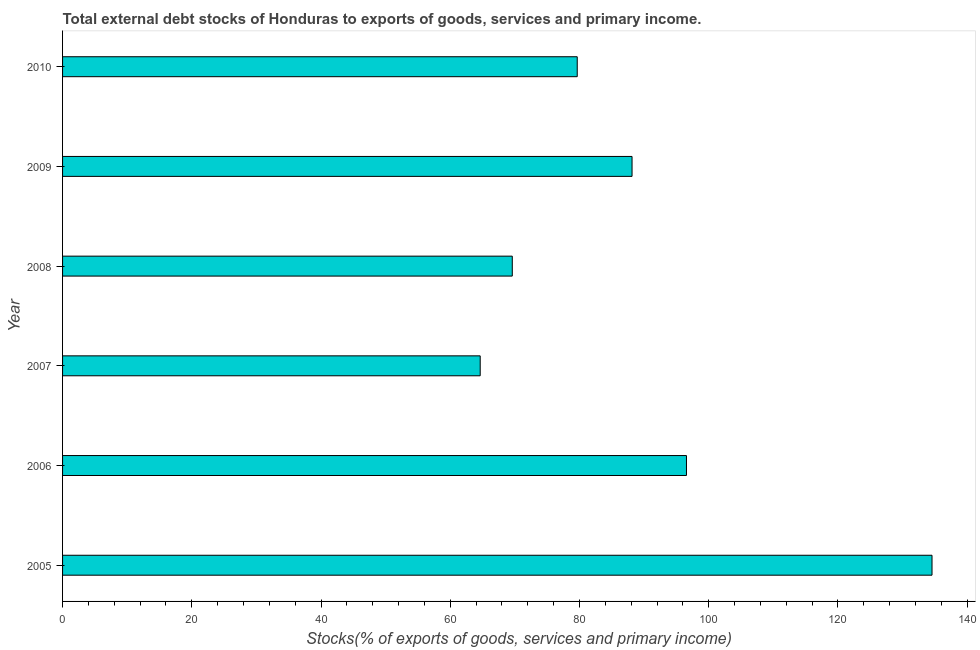What is the title of the graph?
Provide a succinct answer. Total external debt stocks of Honduras to exports of goods, services and primary income. What is the label or title of the X-axis?
Provide a succinct answer. Stocks(% of exports of goods, services and primary income). What is the label or title of the Y-axis?
Offer a very short reply. Year. What is the external debt stocks in 2005?
Give a very brief answer. 134.55. Across all years, what is the maximum external debt stocks?
Ensure brevity in your answer.  134.55. Across all years, what is the minimum external debt stocks?
Provide a short and direct response. 64.63. In which year was the external debt stocks maximum?
Your response must be concise. 2005. In which year was the external debt stocks minimum?
Your response must be concise. 2007. What is the sum of the external debt stocks?
Your response must be concise. 533.11. What is the difference between the external debt stocks in 2005 and 2007?
Your answer should be very brief. 69.92. What is the average external debt stocks per year?
Provide a succinct answer. 88.85. What is the median external debt stocks?
Your answer should be very brief. 83.89. In how many years, is the external debt stocks greater than 76 %?
Give a very brief answer. 4. What is the ratio of the external debt stocks in 2005 to that in 2009?
Provide a succinct answer. 1.53. What is the difference between the highest and the second highest external debt stocks?
Make the answer very short. 38. What is the difference between the highest and the lowest external debt stocks?
Your response must be concise. 69.92. How many bars are there?
Ensure brevity in your answer.  6. What is the difference between two consecutive major ticks on the X-axis?
Your response must be concise. 20. What is the Stocks(% of exports of goods, services and primary income) in 2005?
Keep it short and to the point. 134.55. What is the Stocks(% of exports of goods, services and primary income) of 2006?
Your answer should be compact. 96.55. What is the Stocks(% of exports of goods, services and primary income) in 2007?
Your response must be concise. 64.63. What is the Stocks(% of exports of goods, services and primary income) in 2008?
Provide a short and direct response. 69.6. What is the Stocks(% of exports of goods, services and primary income) of 2009?
Your response must be concise. 88.13. What is the Stocks(% of exports of goods, services and primary income) of 2010?
Offer a very short reply. 79.65. What is the difference between the Stocks(% of exports of goods, services and primary income) in 2005 and 2006?
Provide a succinct answer. 38. What is the difference between the Stocks(% of exports of goods, services and primary income) in 2005 and 2007?
Your response must be concise. 69.92. What is the difference between the Stocks(% of exports of goods, services and primary income) in 2005 and 2008?
Offer a very short reply. 64.96. What is the difference between the Stocks(% of exports of goods, services and primary income) in 2005 and 2009?
Make the answer very short. 46.42. What is the difference between the Stocks(% of exports of goods, services and primary income) in 2005 and 2010?
Your answer should be very brief. 54.91. What is the difference between the Stocks(% of exports of goods, services and primary income) in 2006 and 2007?
Keep it short and to the point. 31.92. What is the difference between the Stocks(% of exports of goods, services and primary income) in 2006 and 2008?
Your response must be concise. 26.96. What is the difference between the Stocks(% of exports of goods, services and primary income) in 2006 and 2009?
Keep it short and to the point. 8.42. What is the difference between the Stocks(% of exports of goods, services and primary income) in 2006 and 2010?
Your answer should be compact. 16.91. What is the difference between the Stocks(% of exports of goods, services and primary income) in 2007 and 2008?
Your answer should be compact. -4.97. What is the difference between the Stocks(% of exports of goods, services and primary income) in 2007 and 2009?
Make the answer very short. -23.5. What is the difference between the Stocks(% of exports of goods, services and primary income) in 2007 and 2010?
Keep it short and to the point. -15.02. What is the difference between the Stocks(% of exports of goods, services and primary income) in 2008 and 2009?
Offer a very short reply. -18.53. What is the difference between the Stocks(% of exports of goods, services and primary income) in 2008 and 2010?
Make the answer very short. -10.05. What is the difference between the Stocks(% of exports of goods, services and primary income) in 2009 and 2010?
Your answer should be very brief. 8.48. What is the ratio of the Stocks(% of exports of goods, services and primary income) in 2005 to that in 2006?
Offer a terse response. 1.39. What is the ratio of the Stocks(% of exports of goods, services and primary income) in 2005 to that in 2007?
Give a very brief answer. 2.08. What is the ratio of the Stocks(% of exports of goods, services and primary income) in 2005 to that in 2008?
Provide a short and direct response. 1.93. What is the ratio of the Stocks(% of exports of goods, services and primary income) in 2005 to that in 2009?
Your answer should be compact. 1.53. What is the ratio of the Stocks(% of exports of goods, services and primary income) in 2005 to that in 2010?
Give a very brief answer. 1.69. What is the ratio of the Stocks(% of exports of goods, services and primary income) in 2006 to that in 2007?
Make the answer very short. 1.49. What is the ratio of the Stocks(% of exports of goods, services and primary income) in 2006 to that in 2008?
Offer a very short reply. 1.39. What is the ratio of the Stocks(% of exports of goods, services and primary income) in 2006 to that in 2009?
Provide a short and direct response. 1.1. What is the ratio of the Stocks(% of exports of goods, services and primary income) in 2006 to that in 2010?
Provide a short and direct response. 1.21. What is the ratio of the Stocks(% of exports of goods, services and primary income) in 2007 to that in 2008?
Offer a terse response. 0.93. What is the ratio of the Stocks(% of exports of goods, services and primary income) in 2007 to that in 2009?
Your response must be concise. 0.73. What is the ratio of the Stocks(% of exports of goods, services and primary income) in 2007 to that in 2010?
Provide a succinct answer. 0.81. What is the ratio of the Stocks(% of exports of goods, services and primary income) in 2008 to that in 2009?
Your answer should be very brief. 0.79. What is the ratio of the Stocks(% of exports of goods, services and primary income) in 2008 to that in 2010?
Provide a short and direct response. 0.87. What is the ratio of the Stocks(% of exports of goods, services and primary income) in 2009 to that in 2010?
Ensure brevity in your answer.  1.11. 